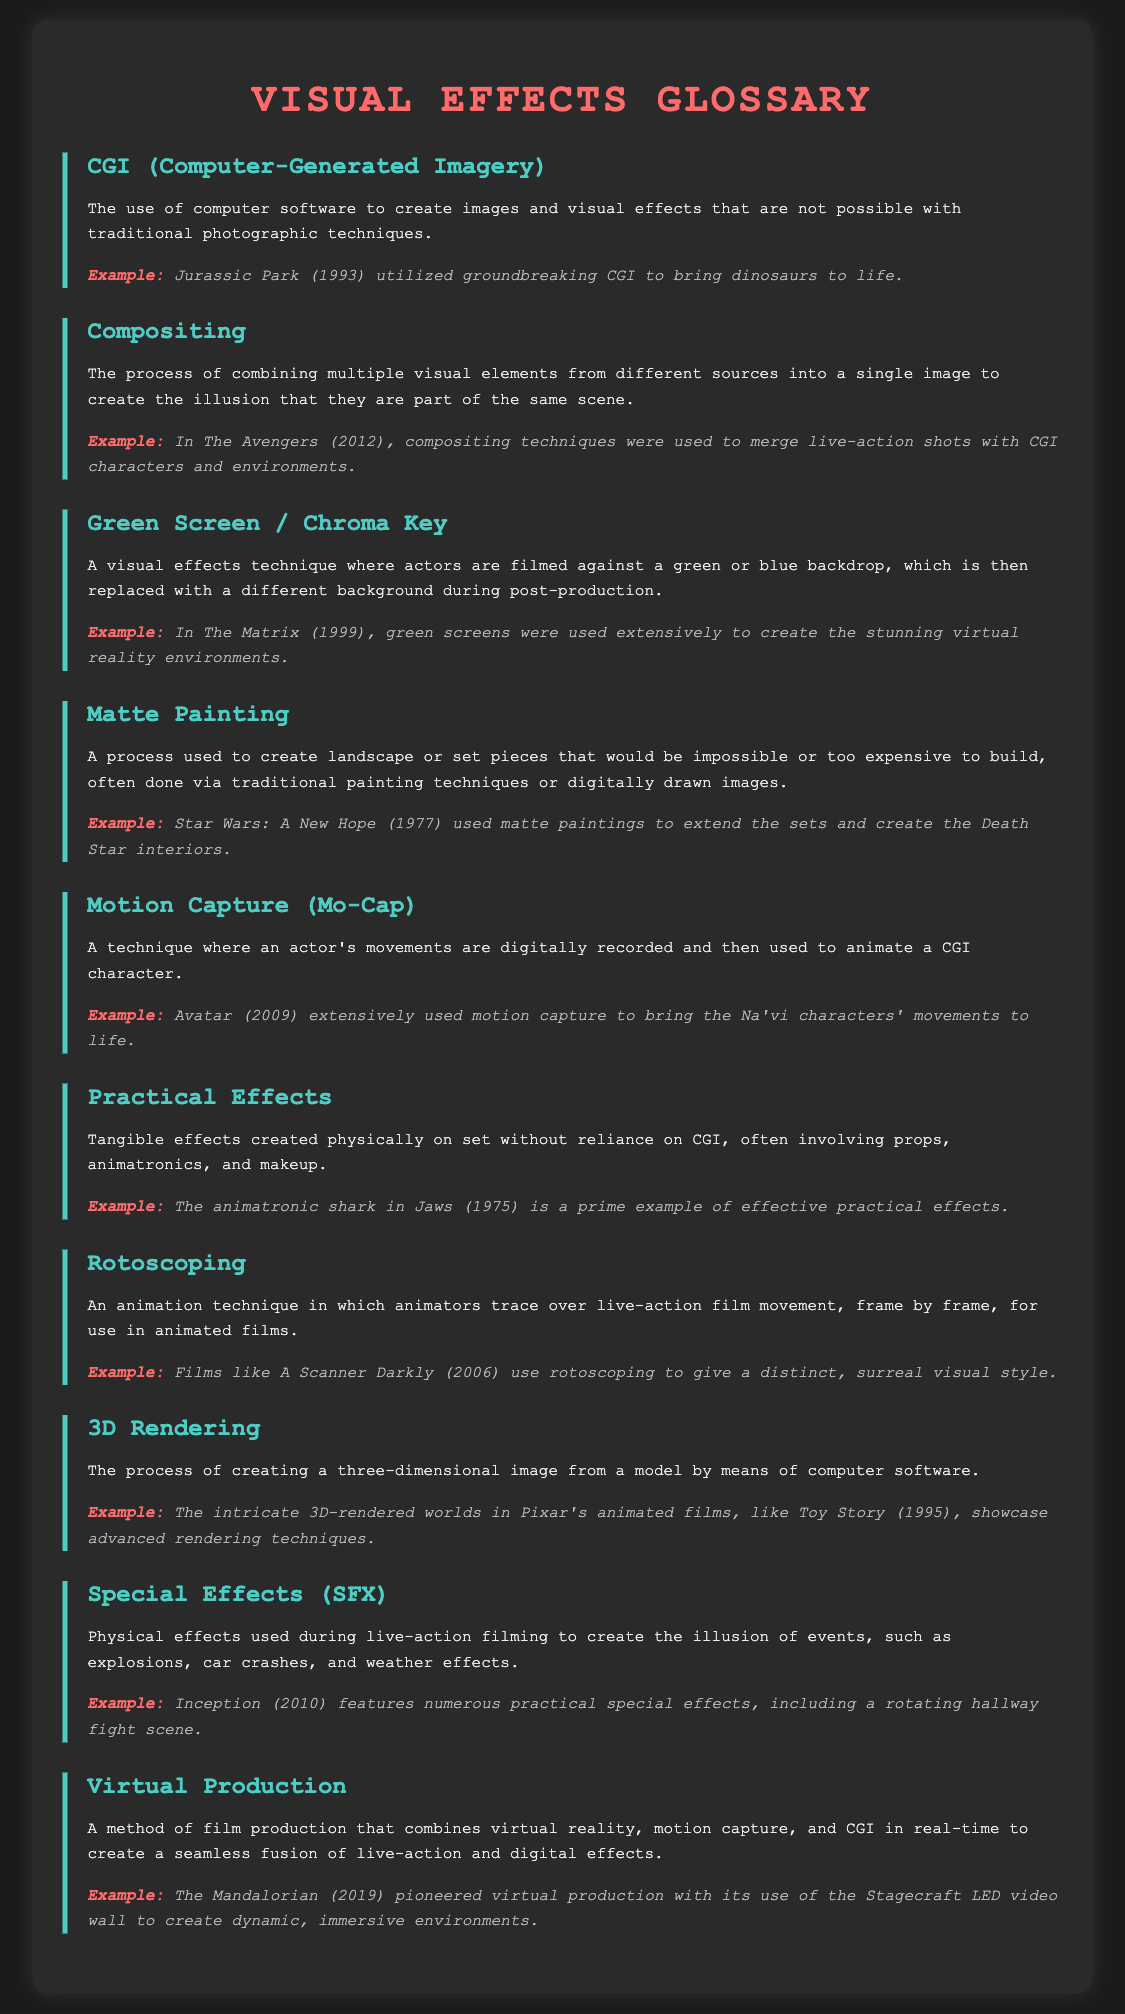What does CGI stand for? CGI stands for Computer-Generated Imagery, which is explained in the document.
Answer: Computer-Generated Imagery Which film is mentioned as using motion capture extensively? The document specifies that Avatar (2009) used motion capture to animate characters.
Answer: Avatar What visual effects technique involves filming against a green backdrop? The document describes Green Screen / Chroma Key as the technique of filming against a green or blue backdrop.
Answer: Green Screen / Chroma Key In which film were matte paintings used to extend sets? Star Wars: A New Hope (1977) is mentioned in the document for its use of matte paintings.
Answer: Star Wars: A New Hope What is the primary focus of practical effects? The document defines practical effects as tangible effects created physically on set without the use of CGI.
Answer: Tangible effects What is the term for combining multiple visual elements into a single image? The document uses the term compositing to describe this process.
Answer: Compositing How does virtual production enhance filmmaking? According to the document, virtual production combines virtual reality, motion capture, and CGI to create a seamless experience.
Answer: Combines virtual reality, motion capture, and CGI What type of animation technique traces over live-action film movement? The document refers to this technique as rotoscoping.
Answer: Rotoscoping Which film features a practical special effect of a rotating hallway fight scene? The document cites Inception (2010) as featuring this special effect.
Answer: Inception 